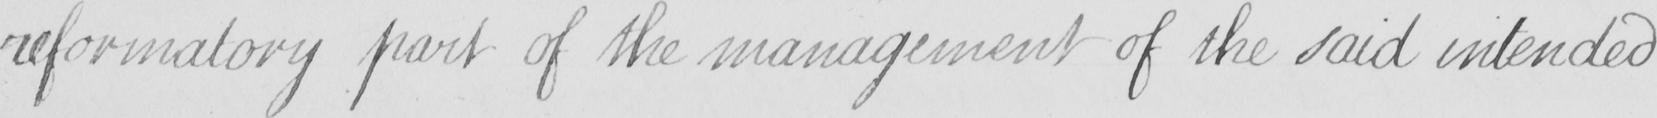What is written in this line of handwriting? reformatory part of the management of the said intended 